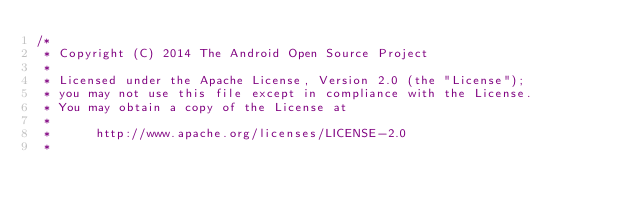Convert code to text. <code><loc_0><loc_0><loc_500><loc_500><_Java_>/*
 * Copyright (C) 2014 The Android Open Source Project
 *
 * Licensed under the Apache License, Version 2.0 (the "License");
 * you may not use this file except in compliance with the License.
 * You may obtain a copy of the License at
 *
 *      http://www.apache.org/licenses/LICENSE-2.0
 *</code> 